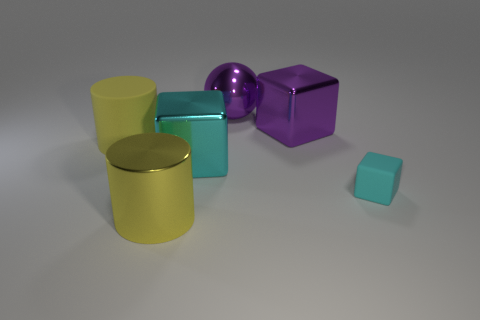Can you describe the shapes and their colors in detail? Certainly! There's a large yellow cylinder, a small aqua cylinder, a large purple cube, a medium-sized spherical object with a reflective surface, and a tiny teal cube, all arranged against a neutral background. How would you say these objects are arranged in terms of depth? The objects are positioned at varying distances. The large yellow cylinder is up front, closely followed by the small aqua cylinder. The reflective sphere and large purple cube are at an intermediate depth, while the tiny teal cube is furthest away, implying a deliberate arrangement by size and depth. 